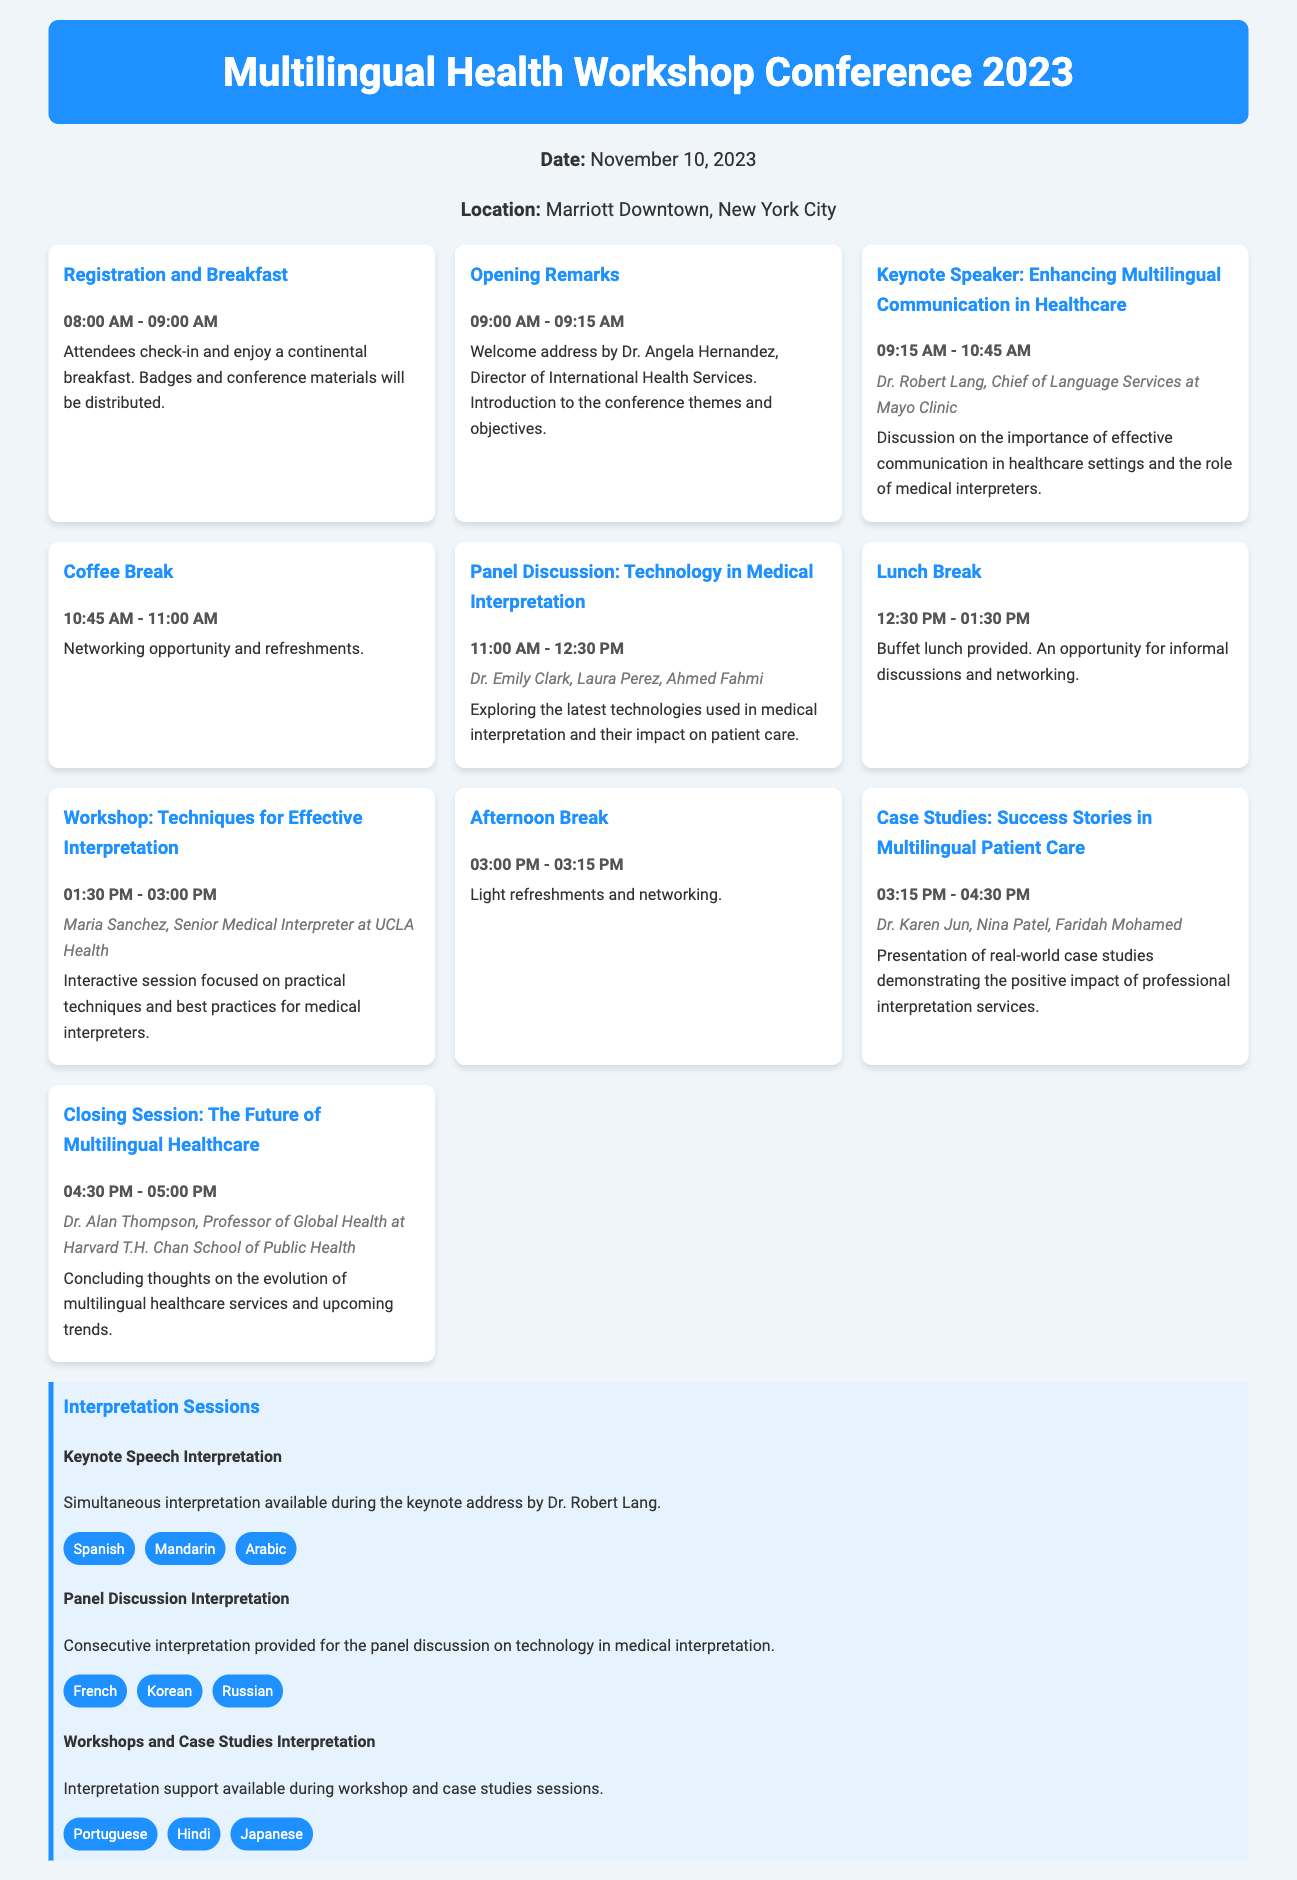What is the date of the conference? The date of the conference is specified in the document.
Answer: November 10, 2023 Where is the conference being held? The location is mentioned in the document.
Answer: Marriott Downtown, New York City Who is the keynote speaker? The document provides the name of the keynote speaker in the agenda.
Answer: Dr. Robert Lang What time does registration start? The document lists the start time for registration in the agenda section.
Answer: 08:00 AM What is the title of the closing session? The title of the closing session is provided in the agenda.
Answer: The Future of Multilingual Healthcare Which language will have simultaneous interpretation during the keynote speech? The document lists the languages available for interpretation during the keynote speech.
Answer: Spanish How long is the lunch break scheduled for? The duration of the lunch break is mentioned in the agenda.
Answer: 1 hour Name one speaker from the panel discussion. The document names the speakers participating in the panel discussion.
Answer: Dr. Emily Clark What type of interpretation is provided during the workshops? The document specifies the type of interpretation available during the workshops.
Answer: Support available Which language is not offered for the panel discussion interpretation? The languages for the panel discussion interpretation are listed in the document.
Answer: Japanese 